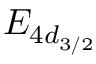<formula> <loc_0><loc_0><loc_500><loc_500>E _ { 4 d _ { 3 / 2 } }</formula> 